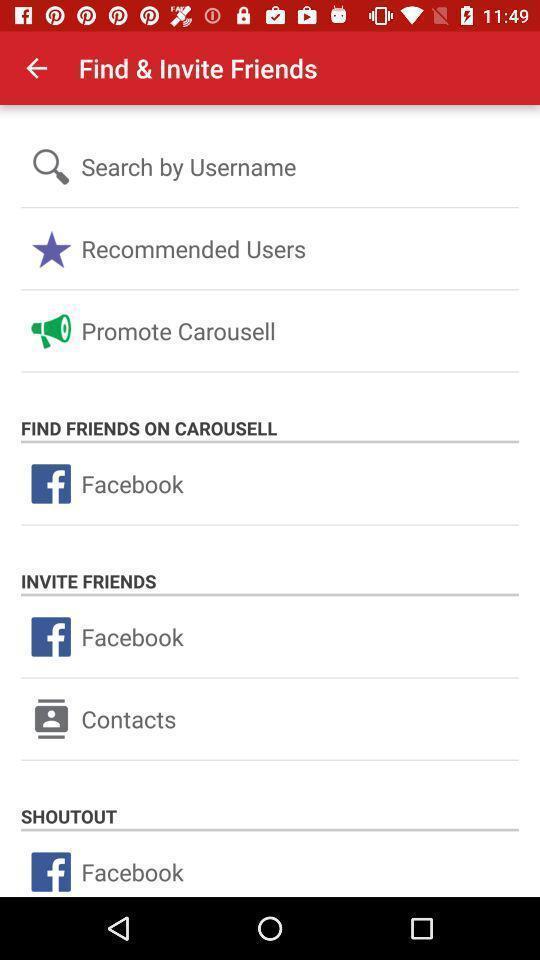Provide a textual representation of this image. Screen displaying multiple options to invite users. 